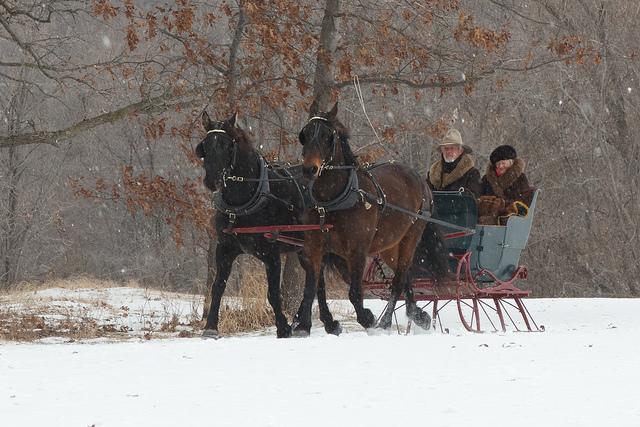Is this an old image?
Write a very short answer. No. Is the horse running?
Quick response, please. No. How many horses are pictured?
Quick response, please. 2. How many people are in this scene?
Give a very brief answer. 2. Is it snowing out?
Keep it brief. Yes. Where is the man sitting?
Quick response, please. Sleigh. Could this picture be on a calendar for animal butts?
Be succinct. No. How many animals are there?
Answer briefly. 2. How many people are riding on this sled?
Give a very brief answer. 2. What are the people riding in?
Give a very brief answer. Sleigh. Is it time to go indoors?
Write a very short answer. No. Is this horse dead now?
Concise answer only. No. How many horses are there?
Keep it brief. 2. What is the color of the horse?
Give a very brief answer. Brown. What color are the horses?
Short answer required. Brown. 